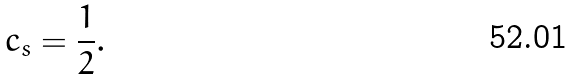<formula> <loc_0><loc_0><loc_500><loc_500>c _ { s } = \frac { 1 } { 2 } .</formula> 